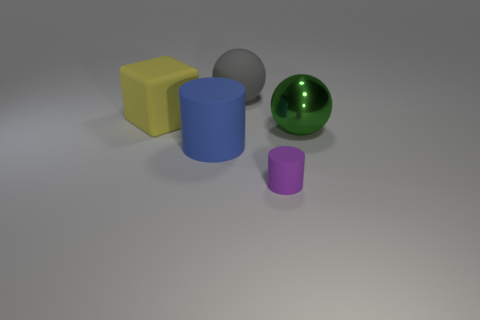What shape is the big thing in front of the big ball on the right side of the matte thing that is on the right side of the big gray ball?
Keep it short and to the point. Cylinder. The small object that is the same material as the large cube is what shape?
Ensure brevity in your answer.  Cylinder. The blue matte cylinder has what size?
Provide a succinct answer. Large. Does the yellow thing have the same size as the green shiny sphere?
Make the answer very short. Yes. What number of things are either large objects that are left of the large metallic object or things that are behind the green shiny thing?
Your answer should be compact. 3. There is a rubber cube in front of the large sphere that is behind the large green sphere; what number of large gray balls are on the right side of it?
Your answer should be very brief. 1. How big is the cylinder in front of the blue thing?
Make the answer very short. Small. What number of purple rubber objects have the same size as the shiny thing?
Provide a short and direct response. 0. Do the green thing and the rubber cylinder right of the big matte ball have the same size?
Ensure brevity in your answer.  No. What number of objects are either large brown shiny things or large things?
Offer a terse response. 4. 